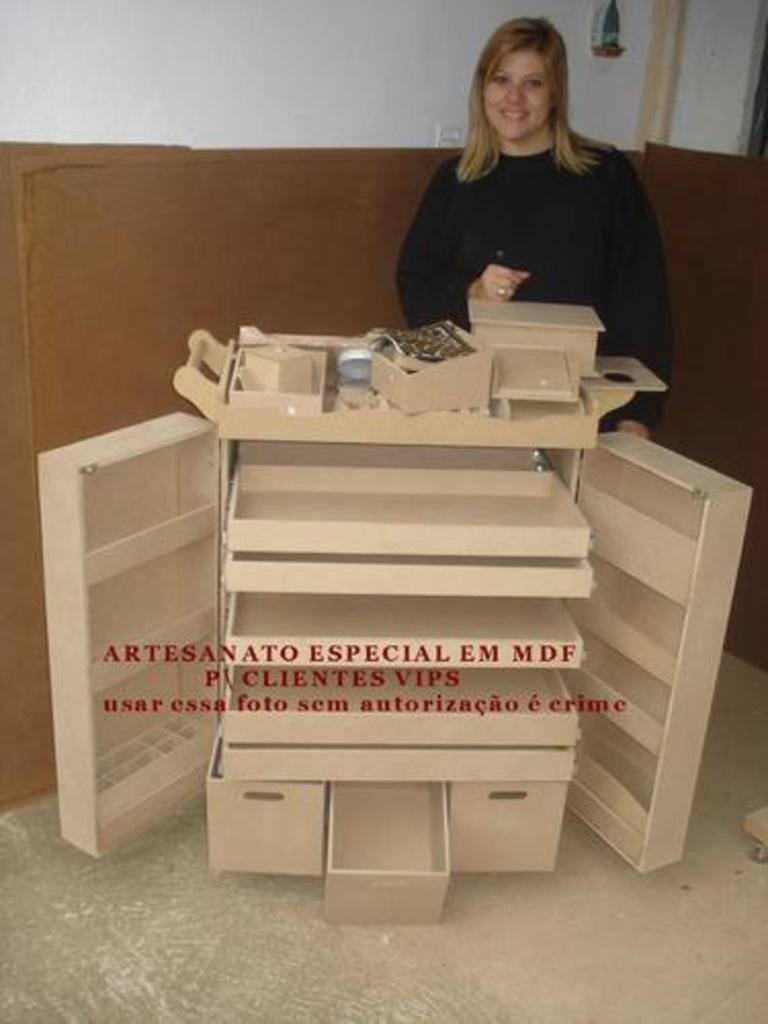Can you describe this image briefly? In this image I can see the person with the black color dress. In-front of the person I can see an object which is in brown color. In the background I can see the wall which is in white and brown color. 